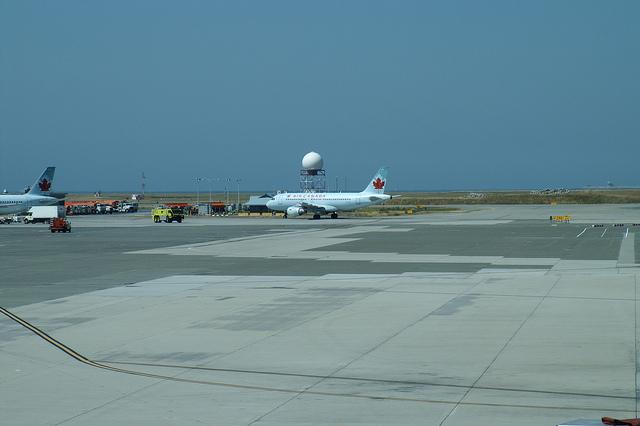Is this a beach?
Be succinct. No. Is this a skate park?
Short answer required. No. Is this a city street?
Answer briefly. No. Could the airplane be from Canada?
Answer briefly. Yes. What is the picture on the side of the plane?
Keep it brief. Maple leaf. Are the units occupied?
Quick response, please. No. How many planes are in the picture?
Concise answer only. 2. Is this plane in motion?
Concise answer only. No. Is there a large body of water?
Write a very short answer. No. How many engines on the plane?
Keep it brief. 2. Could I play basketball here?
Quick response, please. No. Why is the landing gear deployed?
Give a very brief answer. To land. What is floating in the sky?
Be succinct. Nothing. What is in front of the plane?
Write a very short answer. Window. How many planes?
Write a very short answer. 2. Is this a public setting?
Concise answer only. No. What is this aircraft on the runway?
Concise answer only. Airplane. What place is this picture taken?
Answer briefly. Airport. How many airplanes are there?
Concise answer only. 2. 